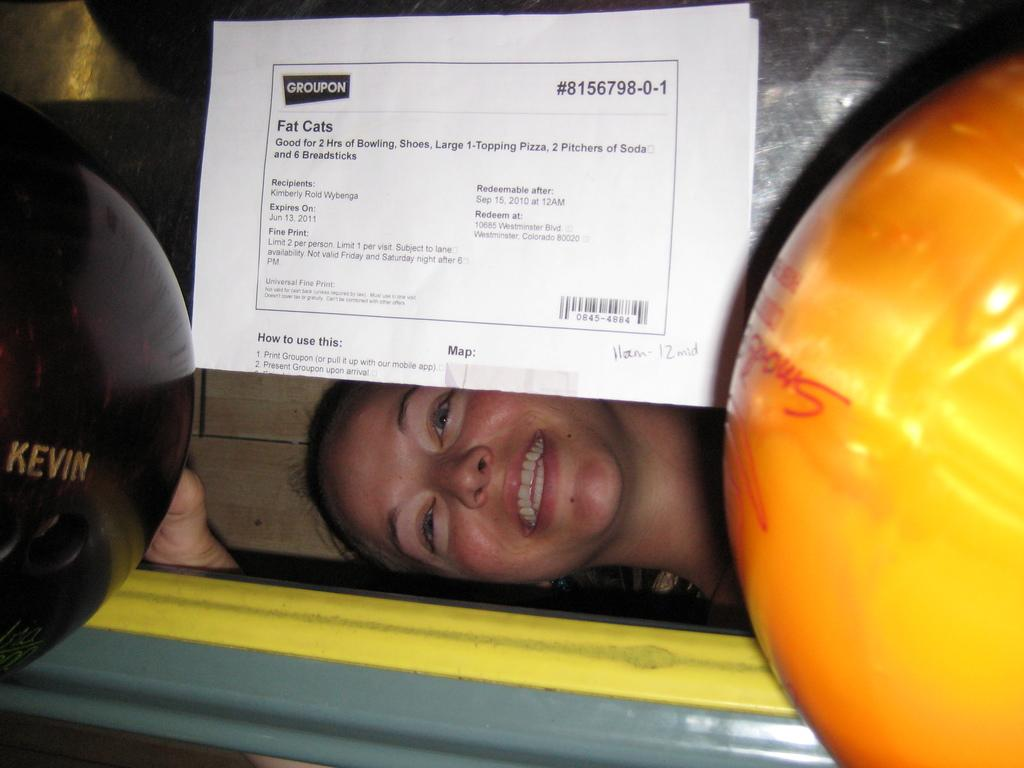What objects can be seen in the image related to a sport? There are two bowling balls in the image. What is attached to the glass in the background of the image? There is a paper stick to the glass in the background of the image. Can you describe the person's expression in the image? A person is smiling in the image. What type of juice is being served at the camp in the image? There is no camp or juice present in the image. Is the doll holding the bowling balls in the image? There is no doll present in the image; only two bowling balls can be seen. 